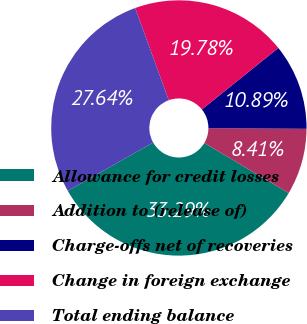Convert chart. <chart><loc_0><loc_0><loc_500><loc_500><pie_chart><fcel>Allowance for credit losses<fcel>Addition to (release of)<fcel>Charge-offs net of recoveries<fcel>Change in foreign exchange<fcel>Total ending balance<nl><fcel>33.29%<fcel>8.41%<fcel>10.89%<fcel>19.78%<fcel>27.64%<nl></chart> 